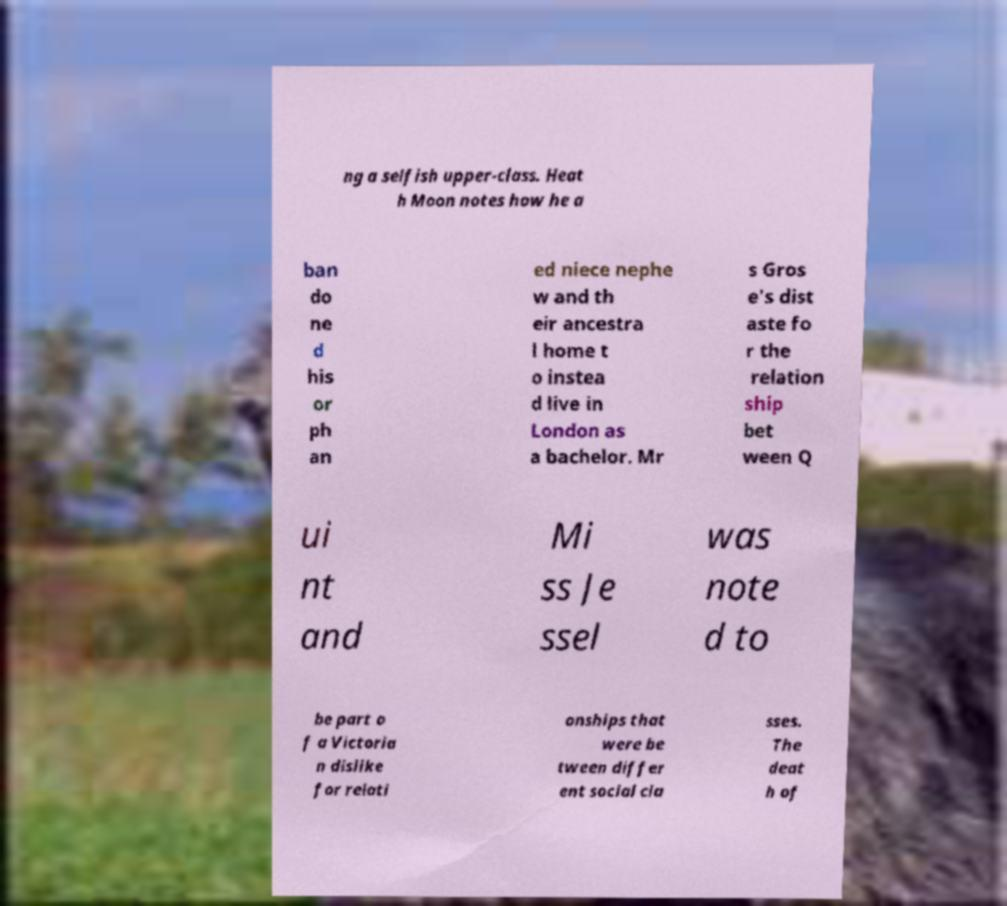Could you assist in decoding the text presented in this image and type it out clearly? ng a selfish upper-class. Heat h Moon notes how he a ban do ne d his or ph an ed niece nephe w and th eir ancestra l home t o instea d live in London as a bachelor. Mr s Gros e's dist aste fo r the relation ship bet ween Q ui nt and Mi ss Je ssel was note d to be part o f a Victoria n dislike for relati onships that were be tween differ ent social cla sses. The deat h of 